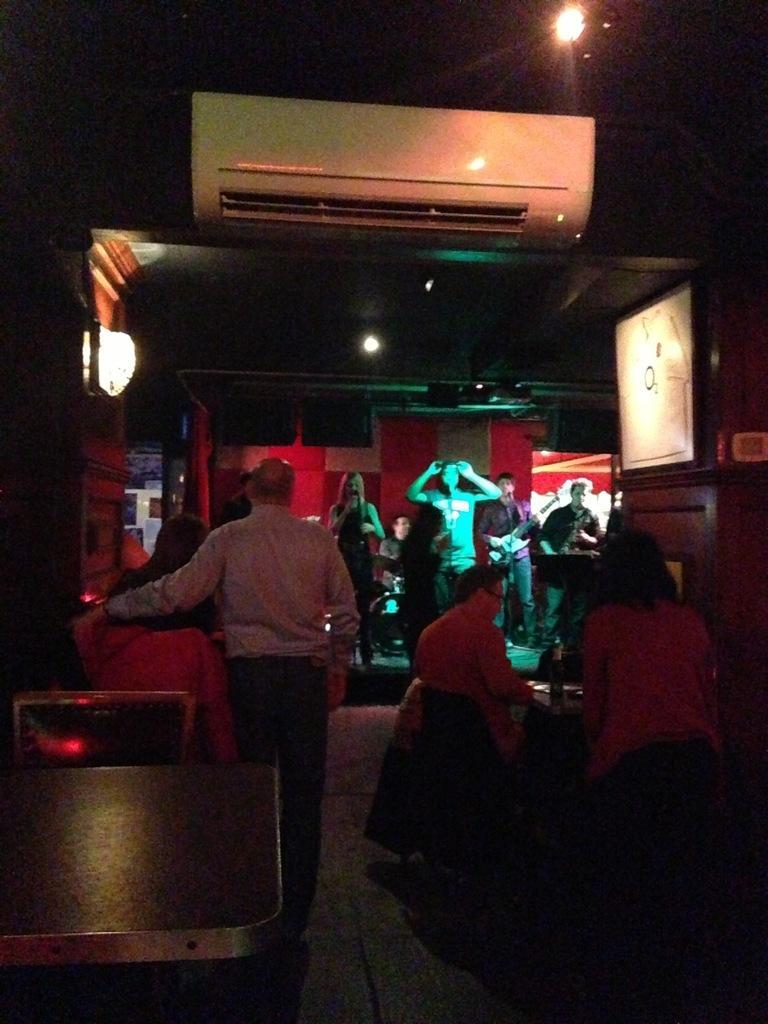In one or two sentences, can you explain what this image depicts? In this image, we can see persons wearing clothes. There is a shelter in the middle of the image. There is a light in the top right of the image. There is a table in the bottom left of the image. 